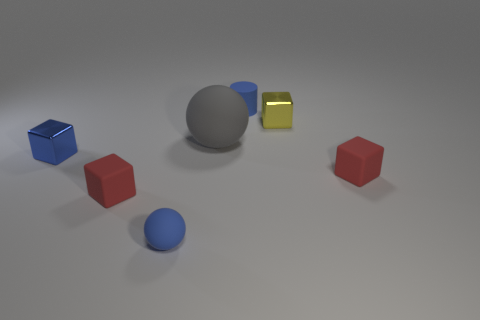Subtract all brown cubes. Subtract all cyan balls. How many cubes are left? 4 Add 1 tiny blue shiny things. How many objects exist? 8 Subtract all blocks. How many objects are left? 3 Subtract 0 green balls. How many objects are left? 7 Subtract all brown cylinders. Subtract all small red rubber cubes. How many objects are left? 5 Add 7 small red rubber blocks. How many small red rubber blocks are left? 9 Add 1 small green metal blocks. How many small green metal blocks exist? 1 